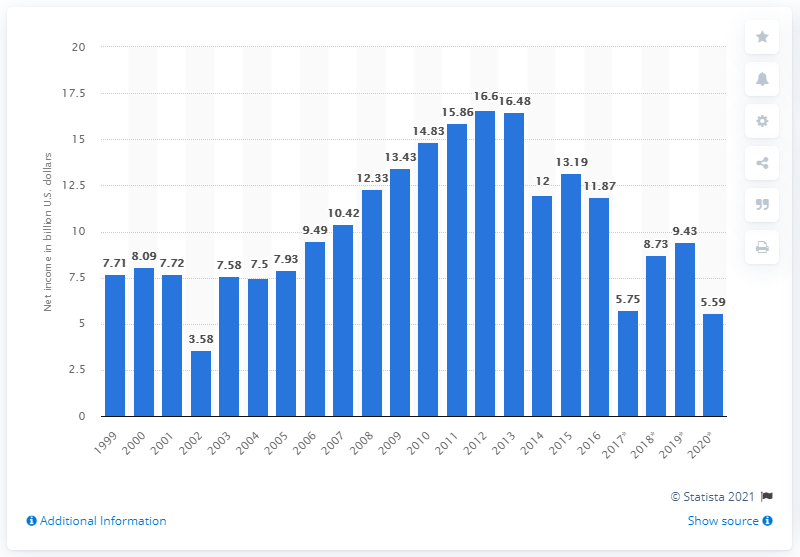Identify some key points in this picture. In 2020, IBM's net income was $5.59 billion. In 2016, IBM changed its method of segment reporting. 